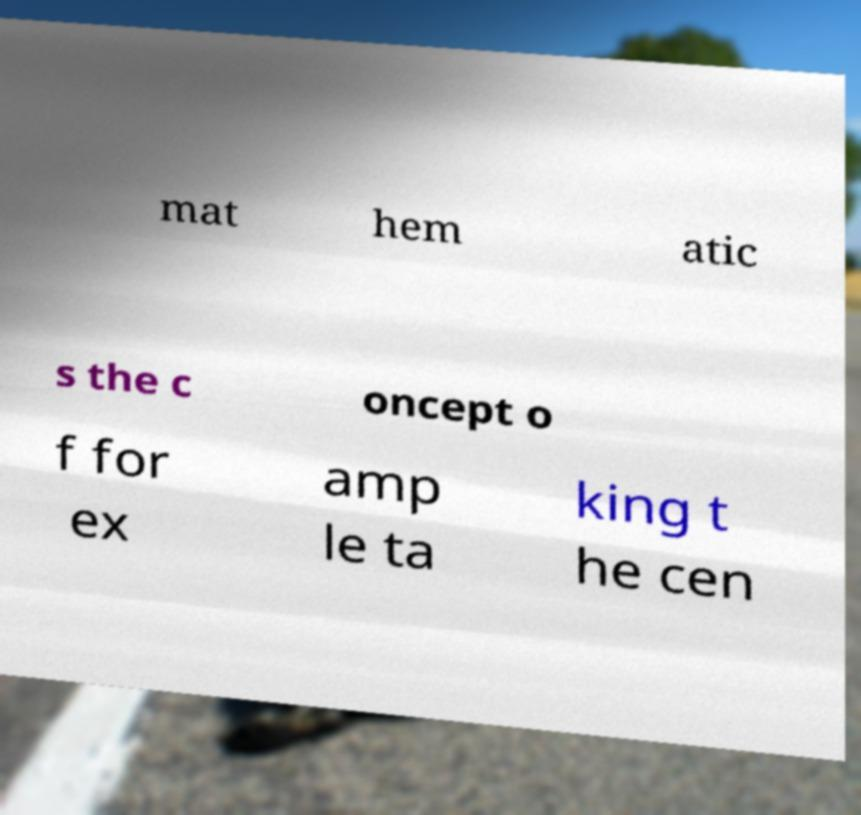Could you extract and type out the text from this image? mat hem atic s the c oncept o f for ex amp le ta king t he cen 